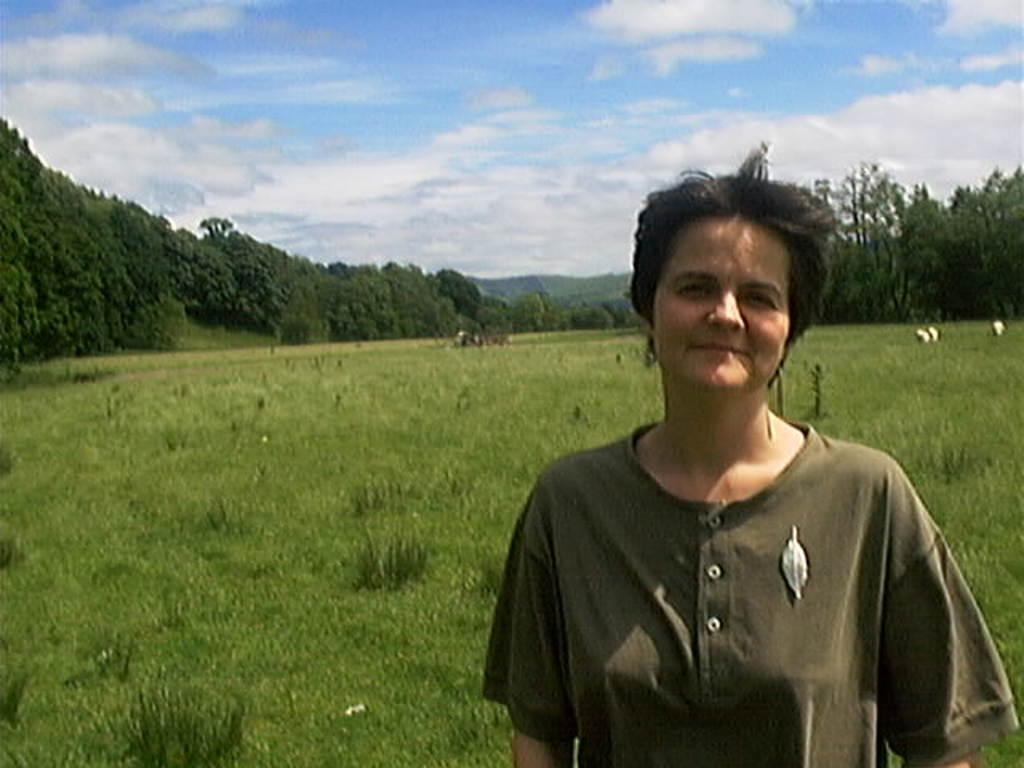Who is present in the image? There is a person in the image. What is the person wearing? The person is wearing clothes. What is the person's facial expression? The person is smiling. What type of vegetation can be seen in the image? There are many trees and grass in the image. How would you describe the sky in the image? The sky is cloudy and pale blue. What impulse does the thing in the image have to interact with the boy? There is no thing or boy present in the image; it only features a person in a natural environment. 